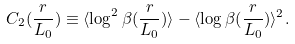<formula> <loc_0><loc_0><loc_500><loc_500>C _ { 2 } ( \frac { r } { L _ { 0 } } ) \equiv \langle \log ^ { 2 } \beta ( \frac { r } { L _ { 0 } } ) \rangle - \langle \log \beta ( \frac { r } { L _ { 0 } } ) \rangle ^ { 2 } .</formula> 